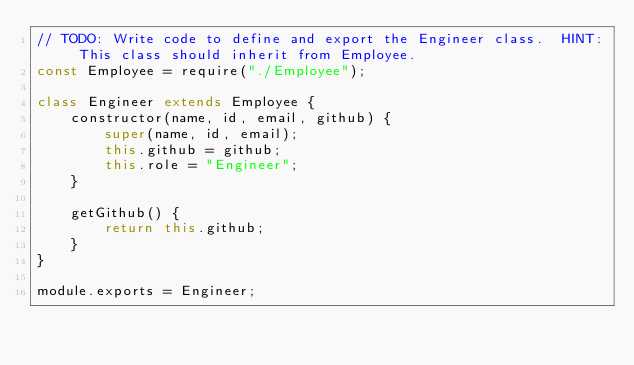<code> <loc_0><loc_0><loc_500><loc_500><_JavaScript_>// TODO: Write code to define and export the Engineer class.  HINT: This class should inherit from Employee.
const Employee = require("./Employee");

class Engineer extends Employee {
    constructor(name, id, email, github) {
        super(name, id, email);
        this.github = github;
        this.role = "Engineer";
    }

    getGithub() {
        return this.github;
    }
}

module.exports = Engineer;</code> 